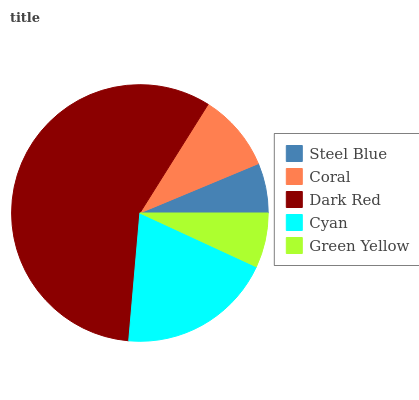Is Steel Blue the minimum?
Answer yes or no. Yes. Is Dark Red the maximum?
Answer yes or no. Yes. Is Coral the minimum?
Answer yes or no. No. Is Coral the maximum?
Answer yes or no. No. Is Coral greater than Steel Blue?
Answer yes or no. Yes. Is Steel Blue less than Coral?
Answer yes or no. Yes. Is Steel Blue greater than Coral?
Answer yes or no. No. Is Coral less than Steel Blue?
Answer yes or no. No. Is Coral the high median?
Answer yes or no. Yes. Is Coral the low median?
Answer yes or no. Yes. Is Steel Blue the high median?
Answer yes or no. No. Is Cyan the low median?
Answer yes or no. No. 